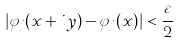<formula> <loc_0><loc_0><loc_500><loc_500>| \varphi _ { j } ( x + i y ) - \varphi _ { j } ( x ) | < \frac { \varepsilon } { 2 }</formula> 